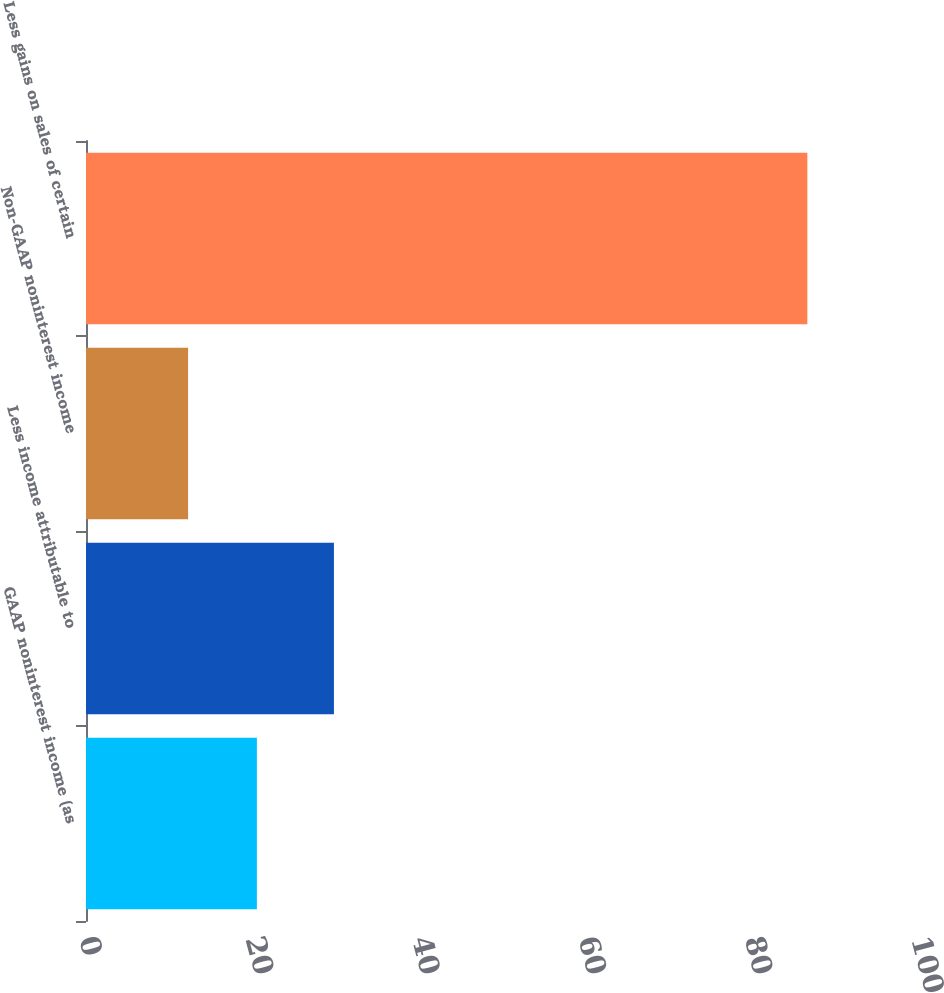Convert chart to OTSL. <chart><loc_0><loc_0><loc_500><loc_500><bar_chart><fcel>GAAP noninterest income (as<fcel>Less income attributable to<fcel>Non-GAAP noninterest income<fcel>Less gains on sales of certain<nl><fcel>20.54<fcel>29.8<fcel>12.27<fcel>86.7<nl></chart> 